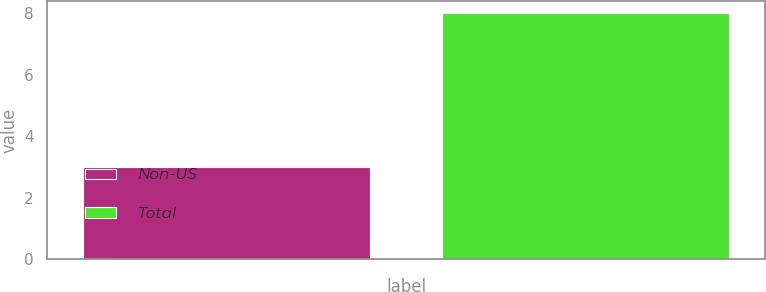Convert chart to OTSL. <chart><loc_0><loc_0><loc_500><loc_500><bar_chart><fcel>Non-US<fcel>Total<nl><fcel>3<fcel>8<nl></chart> 